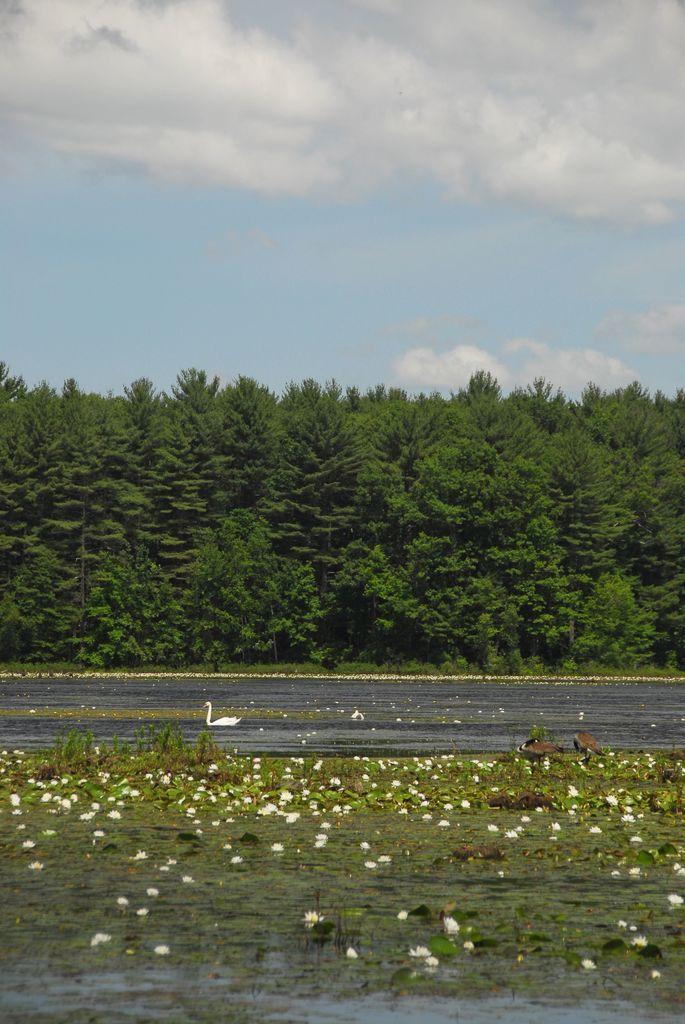Please provide a concise description of this image. In this image we can see a lake. There is a swan in the lake. There are many flowers and plants in the image. There are many trees in the image. There is a blue and a slightly cloudy sky in the image. 